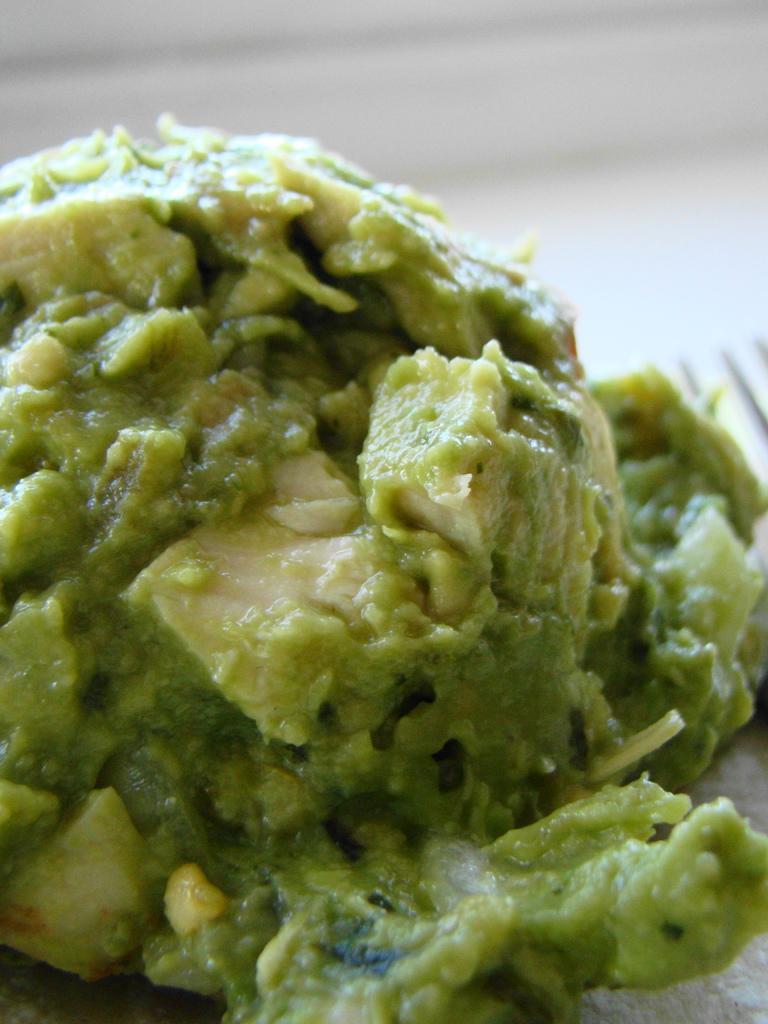Please provide a concise description of this image. In this picture we can see some food in the front, there is a blurry background. 